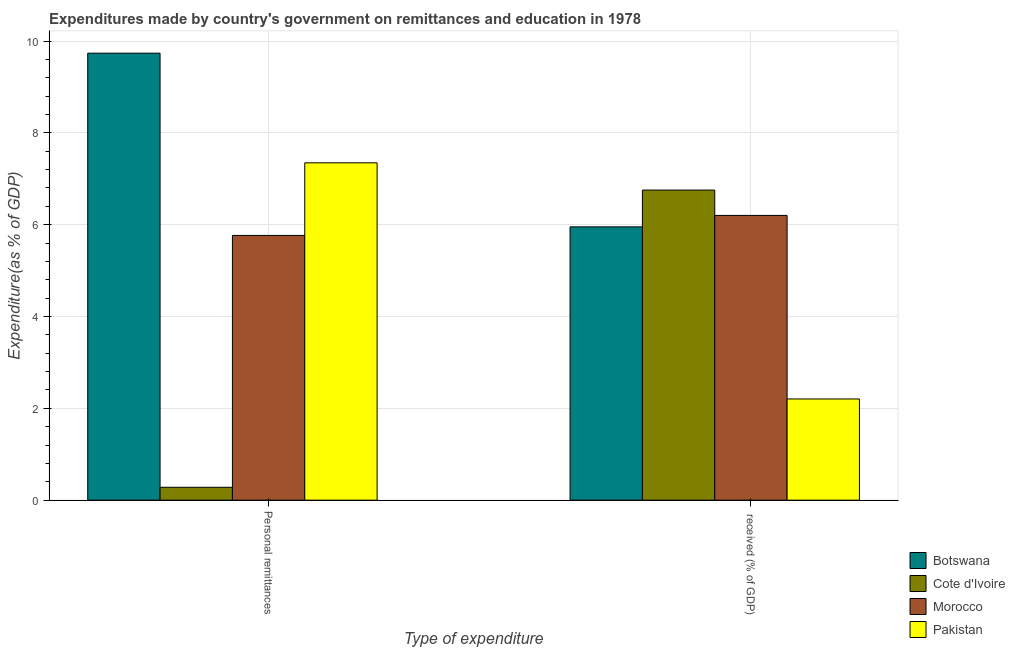Are the number of bars per tick equal to the number of legend labels?
Your response must be concise. Yes. How many bars are there on the 1st tick from the right?
Offer a very short reply. 4. What is the label of the 1st group of bars from the left?
Keep it short and to the point. Personal remittances. What is the expenditure in education in Pakistan?
Your response must be concise. 2.2. Across all countries, what is the maximum expenditure in personal remittances?
Offer a very short reply. 9.74. Across all countries, what is the minimum expenditure in personal remittances?
Keep it short and to the point. 0.28. In which country was the expenditure in education maximum?
Your response must be concise. Cote d'Ivoire. What is the total expenditure in education in the graph?
Your answer should be very brief. 21.11. What is the difference between the expenditure in education in Pakistan and that in Morocco?
Your answer should be very brief. -4. What is the difference between the expenditure in personal remittances in Botswana and the expenditure in education in Morocco?
Give a very brief answer. 3.53. What is the average expenditure in education per country?
Make the answer very short. 5.28. What is the difference between the expenditure in personal remittances and expenditure in education in Botswana?
Your answer should be compact. 3.78. What is the ratio of the expenditure in personal remittances in Botswana to that in Morocco?
Offer a very short reply. 1.69. Is the expenditure in personal remittances in Cote d'Ivoire less than that in Morocco?
Make the answer very short. Yes. What does the 1st bar from the left in Personal remittances represents?
Provide a succinct answer. Botswana. What does the 4th bar from the right in  received (% of GDP) represents?
Ensure brevity in your answer.  Botswana. Are all the bars in the graph horizontal?
Make the answer very short. No. How many countries are there in the graph?
Your answer should be very brief. 4. What is the difference between two consecutive major ticks on the Y-axis?
Provide a succinct answer. 2. Are the values on the major ticks of Y-axis written in scientific E-notation?
Make the answer very short. No. Does the graph contain any zero values?
Provide a succinct answer. No. How are the legend labels stacked?
Your answer should be very brief. Vertical. What is the title of the graph?
Keep it short and to the point. Expenditures made by country's government on remittances and education in 1978. Does "Rwanda" appear as one of the legend labels in the graph?
Your answer should be compact. No. What is the label or title of the X-axis?
Give a very brief answer. Type of expenditure. What is the label or title of the Y-axis?
Provide a short and direct response. Expenditure(as % of GDP). What is the Expenditure(as % of GDP) in Botswana in Personal remittances?
Your answer should be compact. 9.74. What is the Expenditure(as % of GDP) of Cote d'Ivoire in Personal remittances?
Ensure brevity in your answer.  0.28. What is the Expenditure(as % of GDP) in Morocco in Personal remittances?
Your response must be concise. 5.77. What is the Expenditure(as % of GDP) in Pakistan in Personal remittances?
Give a very brief answer. 7.35. What is the Expenditure(as % of GDP) in Botswana in  received (% of GDP)?
Offer a very short reply. 5.95. What is the Expenditure(as % of GDP) of Cote d'Ivoire in  received (% of GDP)?
Your answer should be compact. 6.75. What is the Expenditure(as % of GDP) of Morocco in  received (% of GDP)?
Your answer should be very brief. 6.2. What is the Expenditure(as % of GDP) of Pakistan in  received (% of GDP)?
Make the answer very short. 2.2. Across all Type of expenditure, what is the maximum Expenditure(as % of GDP) of Botswana?
Make the answer very short. 9.74. Across all Type of expenditure, what is the maximum Expenditure(as % of GDP) in Cote d'Ivoire?
Keep it short and to the point. 6.75. Across all Type of expenditure, what is the maximum Expenditure(as % of GDP) of Morocco?
Provide a short and direct response. 6.2. Across all Type of expenditure, what is the maximum Expenditure(as % of GDP) in Pakistan?
Your answer should be very brief. 7.35. Across all Type of expenditure, what is the minimum Expenditure(as % of GDP) of Botswana?
Ensure brevity in your answer.  5.95. Across all Type of expenditure, what is the minimum Expenditure(as % of GDP) of Cote d'Ivoire?
Ensure brevity in your answer.  0.28. Across all Type of expenditure, what is the minimum Expenditure(as % of GDP) of Morocco?
Offer a terse response. 5.77. Across all Type of expenditure, what is the minimum Expenditure(as % of GDP) of Pakistan?
Give a very brief answer. 2.2. What is the total Expenditure(as % of GDP) in Botswana in the graph?
Your response must be concise. 15.69. What is the total Expenditure(as % of GDP) of Cote d'Ivoire in the graph?
Provide a short and direct response. 7.03. What is the total Expenditure(as % of GDP) of Morocco in the graph?
Make the answer very short. 11.97. What is the total Expenditure(as % of GDP) in Pakistan in the graph?
Offer a terse response. 9.55. What is the difference between the Expenditure(as % of GDP) in Botswana in Personal remittances and that in  received (% of GDP)?
Offer a very short reply. 3.78. What is the difference between the Expenditure(as % of GDP) in Cote d'Ivoire in Personal remittances and that in  received (% of GDP)?
Offer a terse response. -6.47. What is the difference between the Expenditure(as % of GDP) of Morocco in Personal remittances and that in  received (% of GDP)?
Your answer should be compact. -0.44. What is the difference between the Expenditure(as % of GDP) in Pakistan in Personal remittances and that in  received (% of GDP)?
Keep it short and to the point. 5.14. What is the difference between the Expenditure(as % of GDP) of Botswana in Personal remittances and the Expenditure(as % of GDP) of Cote d'Ivoire in  received (% of GDP)?
Keep it short and to the point. 2.98. What is the difference between the Expenditure(as % of GDP) of Botswana in Personal remittances and the Expenditure(as % of GDP) of Morocco in  received (% of GDP)?
Give a very brief answer. 3.53. What is the difference between the Expenditure(as % of GDP) of Botswana in Personal remittances and the Expenditure(as % of GDP) of Pakistan in  received (% of GDP)?
Ensure brevity in your answer.  7.53. What is the difference between the Expenditure(as % of GDP) in Cote d'Ivoire in Personal remittances and the Expenditure(as % of GDP) in Morocco in  received (% of GDP)?
Give a very brief answer. -5.92. What is the difference between the Expenditure(as % of GDP) of Cote d'Ivoire in Personal remittances and the Expenditure(as % of GDP) of Pakistan in  received (% of GDP)?
Provide a short and direct response. -1.92. What is the difference between the Expenditure(as % of GDP) in Morocco in Personal remittances and the Expenditure(as % of GDP) in Pakistan in  received (% of GDP)?
Your answer should be compact. 3.56. What is the average Expenditure(as % of GDP) of Botswana per Type of expenditure?
Ensure brevity in your answer.  7.84. What is the average Expenditure(as % of GDP) in Cote d'Ivoire per Type of expenditure?
Make the answer very short. 3.52. What is the average Expenditure(as % of GDP) of Morocco per Type of expenditure?
Offer a terse response. 5.98. What is the average Expenditure(as % of GDP) in Pakistan per Type of expenditure?
Your answer should be very brief. 4.78. What is the difference between the Expenditure(as % of GDP) in Botswana and Expenditure(as % of GDP) in Cote d'Ivoire in Personal remittances?
Your answer should be very brief. 9.45. What is the difference between the Expenditure(as % of GDP) of Botswana and Expenditure(as % of GDP) of Morocco in Personal remittances?
Offer a terse response. 3.97. What is the difference between the Expenditure(as % of GDP) in Botswana and Expenditure(as % of GDP) in Pakistan in Personal remittances?
Make the answer very short. 2.39. What is the difference between the Expenditure(as % of GDP) in Cote d'Ivoire and Expenditure(as % of GDP) in Morocco in Personal remittances?
Offer a terse response. -5.49. What is the difference between the Expenditure(as % of GDP) in Cote d'Ivoire and Expenditure(as % of GDP) in Pakistan in Personal remittances?
Ensure brevity in your answer.  -7.07. What is the difference between the Expenditure(as % of GDP) in Morocco and Expenditure(as % of GDP) in Pakistan in Personal remittances?
Your response must be concise. -1.58. What is the difference between the Expenditure(as % of GDP) of Botswana and Expenditure(as % of GDP) of Cote d'Ivoire in  received (% of GDP)?
Provide a succinct answer. -0.8. What is the difference between the Expenditure(as % of GDP) of Botswana and Expenditure(as % of GDP) of Morocco in  received (% of GDP)?
Keep it short and to the point. -0.25. What is the difference between the Expenditure(as % of GDP) of Botswana and Expenditure(as % of GDP) of Pakistan in  received (% of GDP)?
Your answer should be very brief. 3.75. What is the difference between the Expenditure(as % of GDP) of Cote d'Ivoire and Expenditure(as % of GDP) of Morocco in  received (% of GDP)?
Keep it short and to the point. 0.55. What is the difference between the Expenditure(as % of GDP) in Cote d'Ivoire and Expenditure(as % of GDP) in Pakistan in  received (% of GDP)?
Your answer should be compact. 4.55. What is the difference between the Expenditure(as % of GDP) of Morocco and Expenditure(as % of GDP) of Pakistan in  received (% of GDP)?
Your answer should be very brief. 4. What is the ratio of the Expenditure(as % of GDP) of Botswana in Personal remittances to that in  received (% of GDP)?
Your response must be concise. 1.64. What is the ratio of the Expenditure(as % of GDP) of Cote d'Ivoire in Personal remittances to that in  received (% of GDP)?
Your answer should be compact. 0.04. What is the ratio of the Expenditure(as % of GDP) of Morocco in Personal remittances to that in  received (% of GDP)?
Your answer should be very brief. 0.93. What is the ratio of the Expenditure(as % of GDP) of Pakistan in Personal remittances to that in  received (% of GDP)?
Give a very brief answer. 3.33. What is the difference between the highest and the second highest Expenditure(as % of GDP) of Botswana?
Offer a very short reply. 3.78. What is the difference between the highest and the second highest Expenditure(as % of GDP) of Cote d'Ivoire?
Make the answer very short. 6.47. What is the difference between the highest and the second highest Expenditure(as % of GDP) of Morocco?
Keep it short and to the point. 0.44. What is the difference between the highest and the second highest Expenditure(as % of GDP) of Pakistan?
Your answer should be compact. 5.14. What is the difference between the highest and the lowest Expenditure(as % of GDP) of Botswana?
Ensure brevity in your answer.  3.78. What is the difference between the highest and the lowest Expenditure(as % of GDP) of Cote d'Ivoire?
Provide a short and direct response. 6.47. What is the difference between the highest and the lowest Expenditure(as % of GDP) of Morocco?
Ensure brevity in your answer.  0.44. What is the difference between the highest and the lowest Expenditure(as % of GDP) of Pakistan?
Provide a short and direct response. 5.14. 